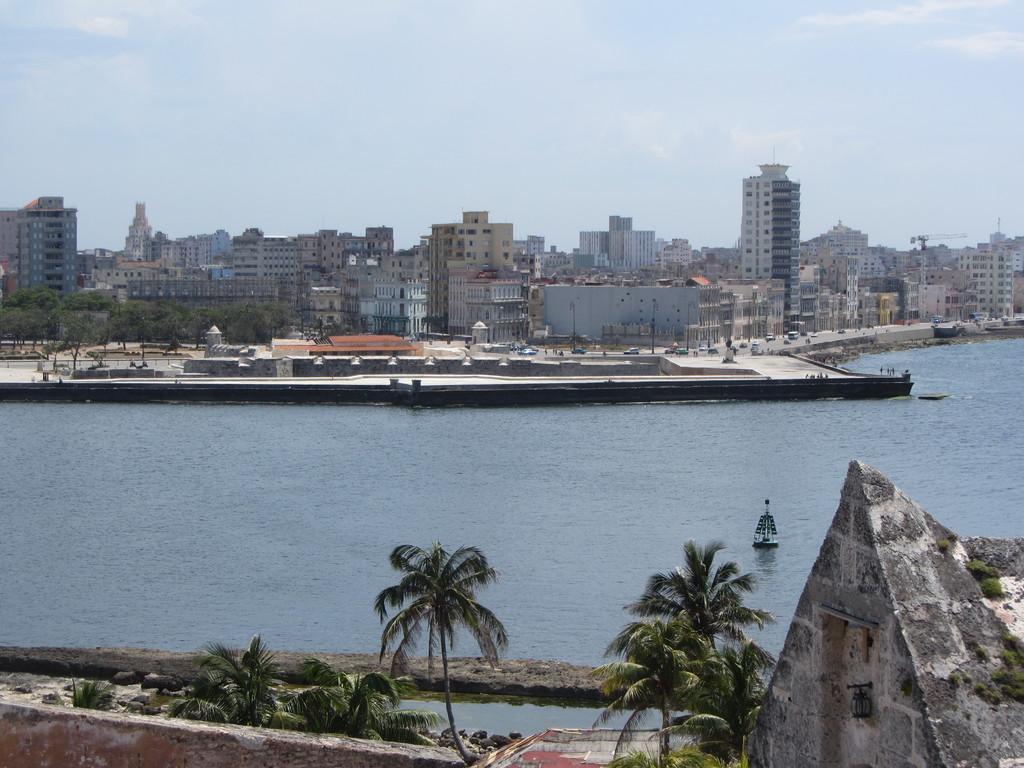Could you give a brief overview of what you see in this image? In the center of the image there is a boat on the river, on the either side of the river there are trees and buildings. 